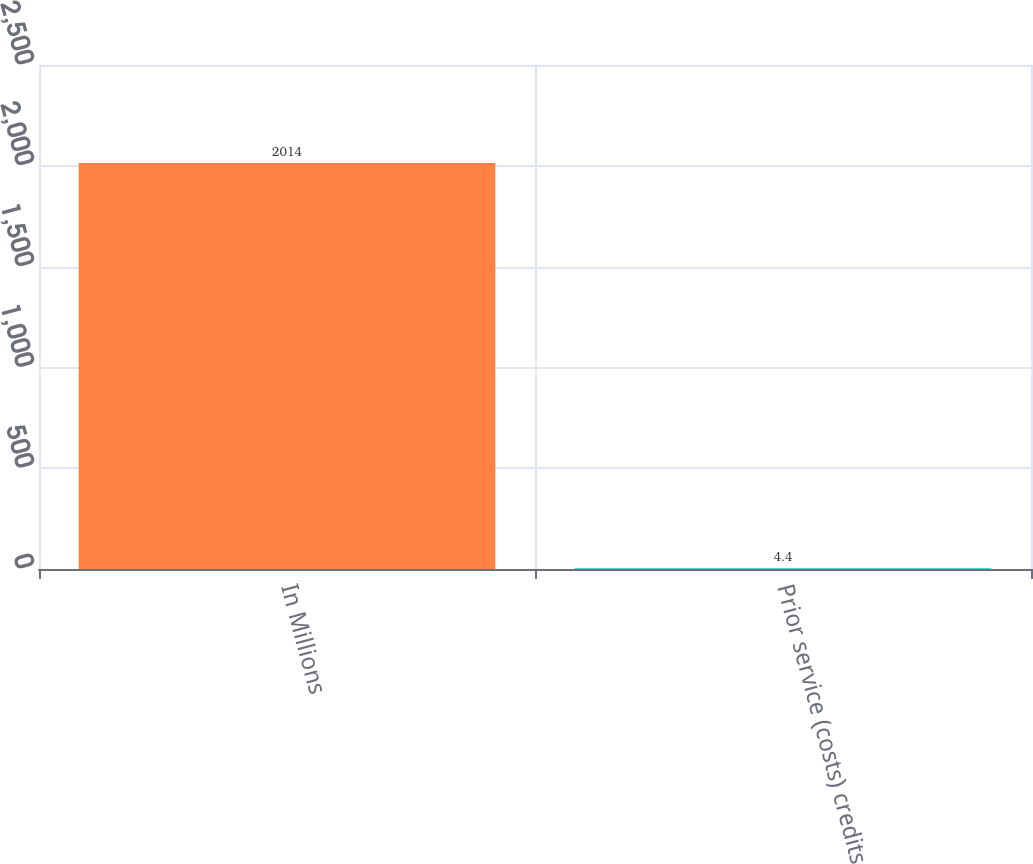Convert chart to OTSL. <chart><loc_0><loc_0><loc_500><loc_500><bar_chart><fcel>In Millions<fcel>Prior service (costs) credits<nl><fcel>2014<fcel>4.4<nl></chart> 